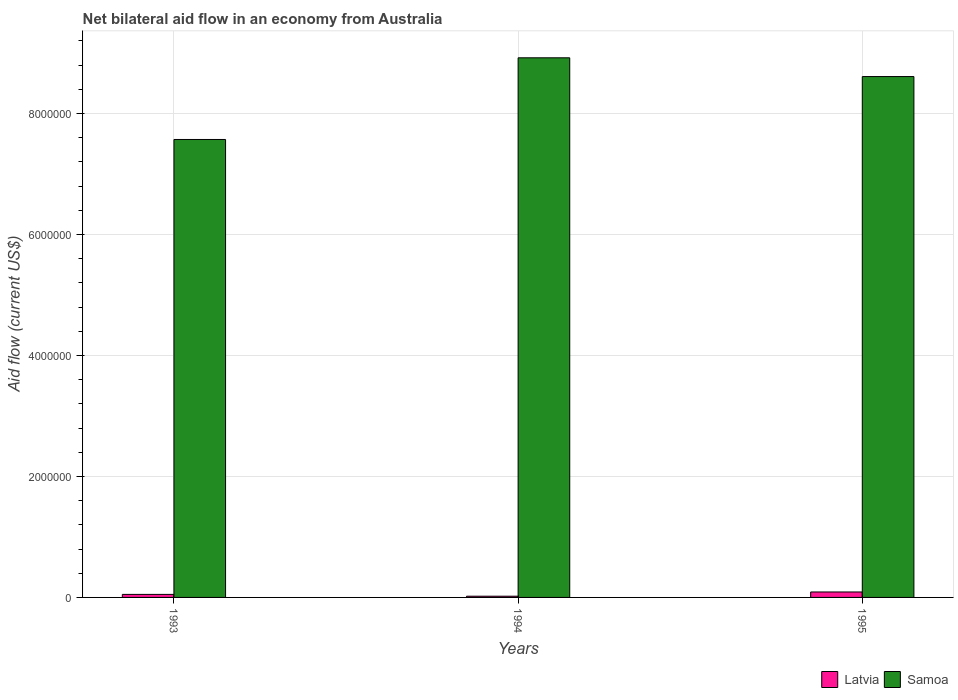How many bars are there on the 3rd tick from the left?
Offer a very short reply. 2. In how many cases, is the number of bars for a given year not equal to the number of legend labels?
Make the answer very short. 0. What is the net bilateral aid flow in Latvia in 1995?
Provide a succinct answer. 9.00e+04. Across all years, what is the maximum net bilateral aid flow in Latvia?
Your answer should be compact. 9.00e+04. Across all years, what is the minimum net bilateral aid flow in Latvia?
Make the answer very short. 2.00e+04. In which year was the net bilateral aid flow in Latvia maximum?
Your response must be concise. 1995. What is the total net bilateral aid flow in Samoa in the graph?
Give a very brief answer. 2.51e+07. What is the difference between the net bilateral aid flow in Samoa in 1994 and the net bilateral aid flow in Latvia in 1995?
Your answer should be very brief. 8.83e+06. What is the average net bilateral aid flow in Samoa per year?
Keep it short and to the point. 8.37e+06. In the year 1994, what is the difference between the net bilateral aid flow in Latvia and net bilateral aid flow in Samoa?
Give a very brief answer. -8.90e+06. What is the ratio of the net bilateral aid flow in Latvia in 1993 to that in 1995?
Ensure brevity in your answer.  0.56. Is the difference between the net bilateral aid flow in Latvia in 1993 and 1995 greater than the difference between the net bilateral aid flow in Samoa in 1993 and 1995?
Give a very brief answer. Yes. What is the difference between the highest and the second highest net bilateral aid flow in Samoa?
Your answer should be compact. 3.10e+05. What is the difference between the highest and the lowest net bilateral aid flow in Samoa?
Provide a short and direct response. 1.35e+06. Is the sum of the net bilateral aid flow in Latvia in 1993 and 1995 greater than the maximum net bilateral aid flow in Samoa across all years?
Give a very brief answer. No. What does the 1st bar from the left in 1994 represents?
Offer a terse response. Latvia. What does the 2nd bar from the right in 1993 represents?
Your answer should be compact. Latvia. How many bars are there?
Keep it short and to the point. 6. How many years are there in the graph?
Your answer should be compact. 3. Where does the legend appear in the graph?
Offer a terse response. Bottom right. How many legend labels are there?
Provide a short and direct response. 2. How are the legend labels stacked?
Give a very brief answer. Horizontal. What is the title of the graph?
Make the answer very short. Net bilateral aid flow in an economy from Australia. Does "Mali" appear as one of the legend labels in the graph?
Offer a very short reply. No. What is the Aid flow (current US$) of Samoa in 1993?
Your response must be concise. 7.57e+06. What is the Aid flow (current US$) in Latvia in 1994?
Give a very brief answer. 2.00e+04. What is the Aid flow (current US$) of Samoa in 1994?
Give a very brief answer. 8.92e+06. What is the Aid flow (current US$) of Latvia in 1995?
Your response must be concise. 9.00e+04. What is the Aid flow (current US$) in Samoa in 1995?
Provide a succinct answer. 8.61e+06. Across all years, what is the maximum Aid flow (current US$) in Samoa?
Keep it short and to the point. 8.92e+06. Across all years, what is the minimum Aid flow (current US$) in Latvia?
Offer a very short reply. 2.00e+04. Across all years, what is the minimum Aid flow (current US$) in Samoa?
Your answer should be very brief. 7.57e+06. What is the total Aid flow (current US$) of Samoa in the graph?
Offer a very short reply. 2.51e+07. What is the difference between the Aid flow (current US$) of Samoa in 1993 and that in 1994?
Ensure brevity in your answer.  -1.35e+06. What is the difference between the Aid flow (current US$) of Samoa in 1993 and that in 1995?
Provide a succinct answer. -1.04e+06. What is the difference between the Aid flow (current US$) in Samoa in 1994 and that in 1995?
Keep it short and to the point. 3.10e+05. What is the difference between the Aid flow (current US$) of Latvia in 1993 and the Aid flow (current US$) of Samoa in 1994?
Make the answer very short. -8.87e+06. What is the difference between the Aid flow (current US$) of Latvia in 1993 and the Aid flow (current US$) of Samoa in 1995?
Your answer should be compact. -8.56e+06. What is the difference between the Aid flow (current US$) in Latvia in 1994 and the Aid flow (current US$) in Samoa in 1995?
Your response must be concise. -8.59e+06. What is the average Aid flow (current US$) of Latvia per year?
Ensure brevity in your answer.  5.33e+04. What is the average Aid flow (current US$) of Samoa per year?
Offer a very short reply. 8.37e+06. In the year 1993, what is the difference between the Aid flow (current US$) of Latvia and Aid flow (current US$) of Samoa?
Your response must be concise. -7.52e+06. In the year 1994, what is the difference between the Aid flow (current US$) in Latvia and Aid flow (current US$) in Samoa?
Provide a succinct answer. -8.90e+06. In the year 1995, what is the difference between the Aid flow (current US$) in Latvia and Aid flow (current US$) in Samoa?
Offer a terse response. -8.52e+06. What is the ratio of the Aid flow (current US$) of Samoa in 1993 to that in 1994?
Offer a terse response. 0.85. What is the ratio of the Aid flow (current US$) in Latvia in 1993 to that in 1995?
Ensure brevity in your answer.  0.56. What is the ratio of the Aid flow (current US$) in Samoa in 1993 to that in 1995?
Make the answer very short. 0.88. What is the ratio of the Aid flow (current US$) of Latvia in 1994 to that in 1995?
Your answer should be very brief. 0.22. What is the ratio of the Aid flow (current US$) of Samoa in 1994 to that in 1995?
Offer a very short reply. 1.04. What is the difference between the highest and the second highest Aid flow (current US$) in Samoa?
Provide a succinct answer. 3.10e+05. What is the difference between the highest and the lowest Aid flow (current US$) in Latvia?
Provide a succinct answer. 7.00e+04. What is the difference between the highest and the lowest Aid flow (current US$) of Samoa?
Make the answer very short. 1.35e+06. 